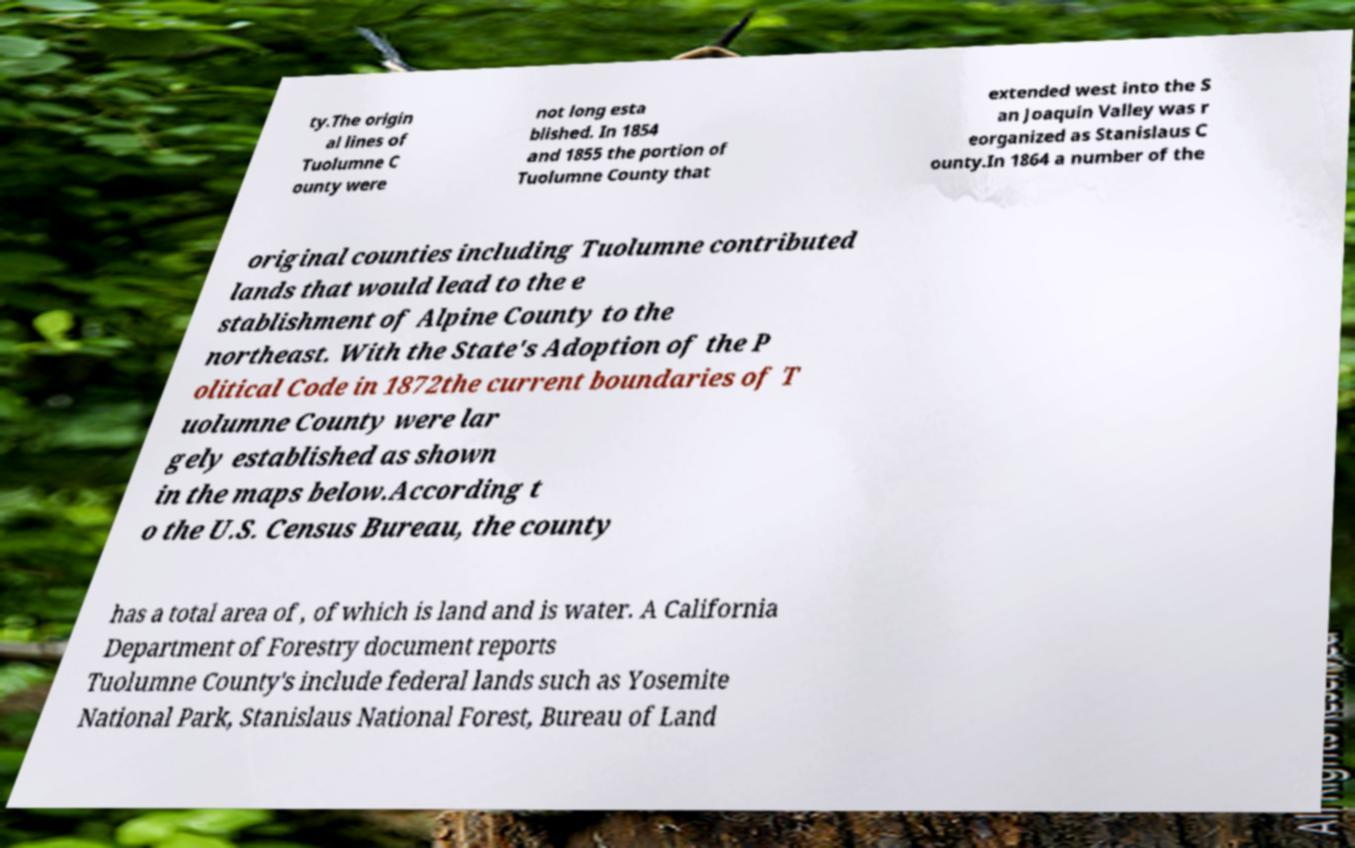I need the written content from this picture converted into text. Can you do that? ty.The origin al lines of Tuolumne C ounty were not long esta blished. In 1854 and 1855 the portion of Tuolumne County that extended west into the S an Joaquin Valley was r eorganized as Stanislaus C ounty.In 1864 a number of the original counties including Tuolumne contributed lands that would lead to the e stablishment of Alpine County to the northeast. With the State's Adoption of the P olitical Code in 1872the current boundaries of T uolumne County were lar gely established as shown in the maps below.According t o the U.S. Census Bureau, the county has a total area of , of which is land and is water. A California Department of Forestry document reports Tuolumne County's include federal lands such as Yosemite National Park, Stanislaus National Forest, Bureau of Land 